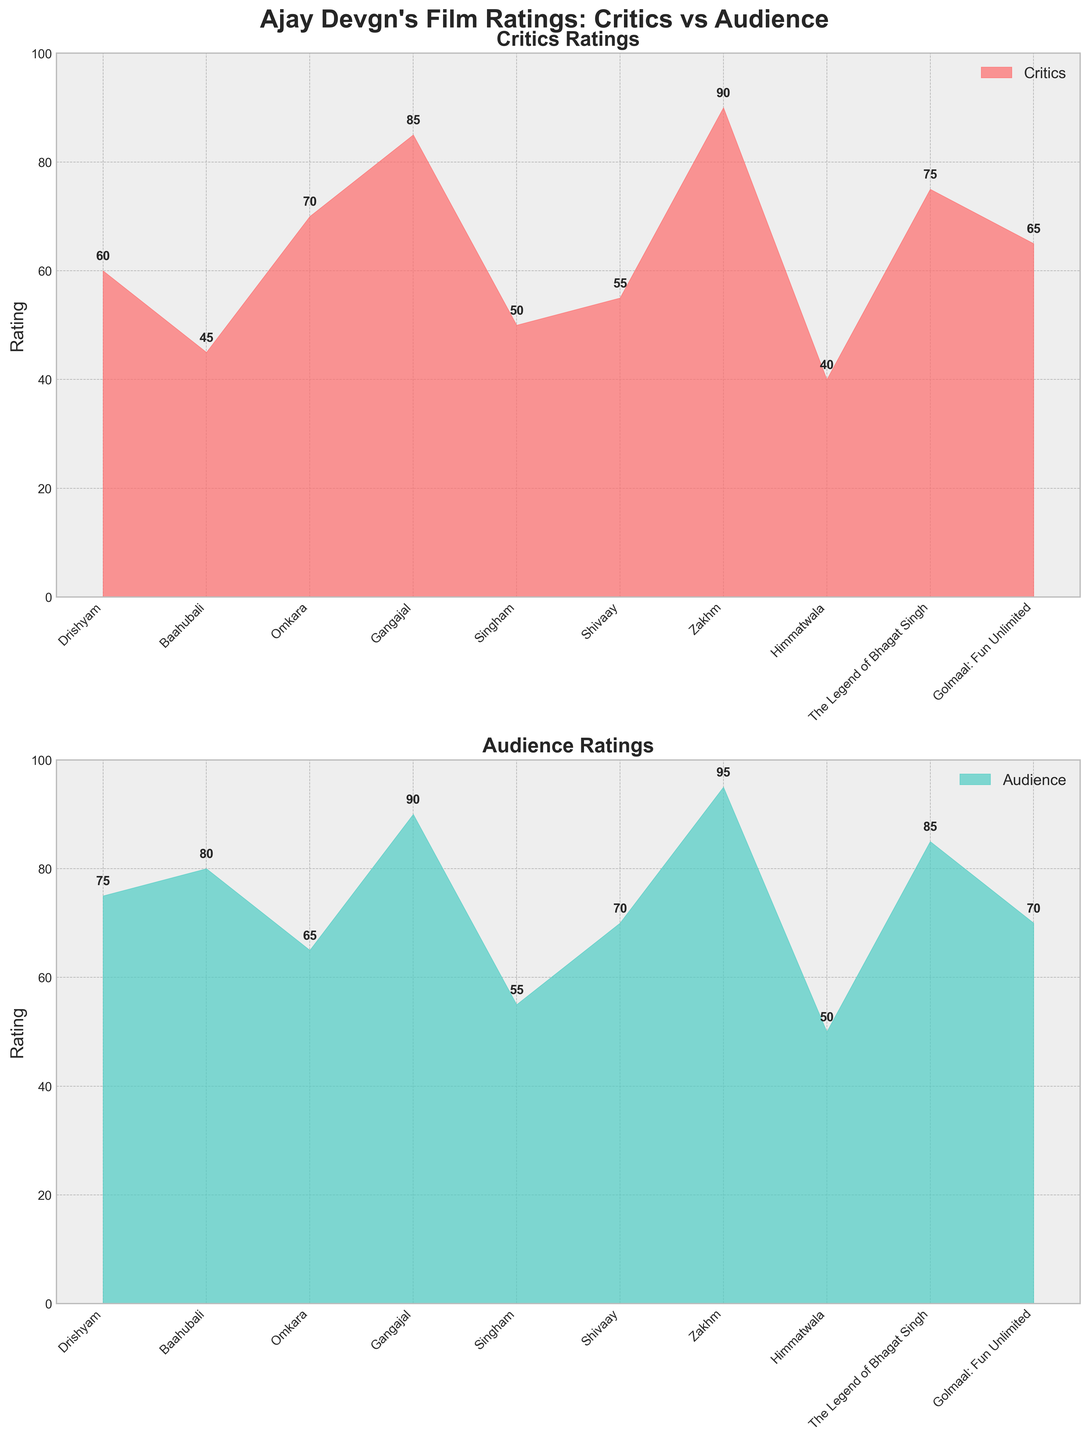What is the title of the figure? The title is located at the very top of the figure, prominently displayed in bold font. It summarizes the content of the plots.
Answer: "Ajay Devgn's Film Ratings: Critics vs Audience" How many films are shown in the figure? To find the number of films, count the number of distinct data points labeled along the x-axis in either of the subplots.
Answer: 10 Which film received the highest rating from critics? Look at the 'Critics Ratings' subplot and find the highest point on the y-axis, then identify the corresponding film on the x-axis.
Answer: Zakhm What is the average rating given by the audience across all films? Add all the audience ratings from the second subplot, then divide by the number of films to find the average: (75+80+65+90+55+70+95+50+85+70) / 10 = 73.5.
Answer: 73.5 Which film had the largest difference between audience and critics' ratings? Subtract the critics' rating from the audience rating for each film, then find the film with the largest absolute difference.
Answer: Baahubali Compare the ratings of "Singham" from critics and audience, which is higher? Find "Singham" on the x-axis in both subplots and compare the heights of the ratings.
Answer: Audience What color is used to represent the critics' ratings? Observe the color filling the area under the critics' ratings line in the first subplot.
Answer: Red Which film received exactly equal ratings from both critics and the audience? Look for films where the heights of the points in both subplots are equal.
Answer: None What is the trend in ratings for "Gangajal" in terms of critics and audience? Examine the positions of "Gangajal" on both subplots. Both ratings are high, indicating positive reviews from both groups.
Answer: Positive from both How does the critics' rating for "Himmatwala" compare to that of "Golmaal: Fun Unlimited"? Compare the heights of the points for "Himmatwala" and "Golmaal: Fun Unlimited" in the critics' subplot.
Answer: Golmaal: Fun Unlimited is higher 